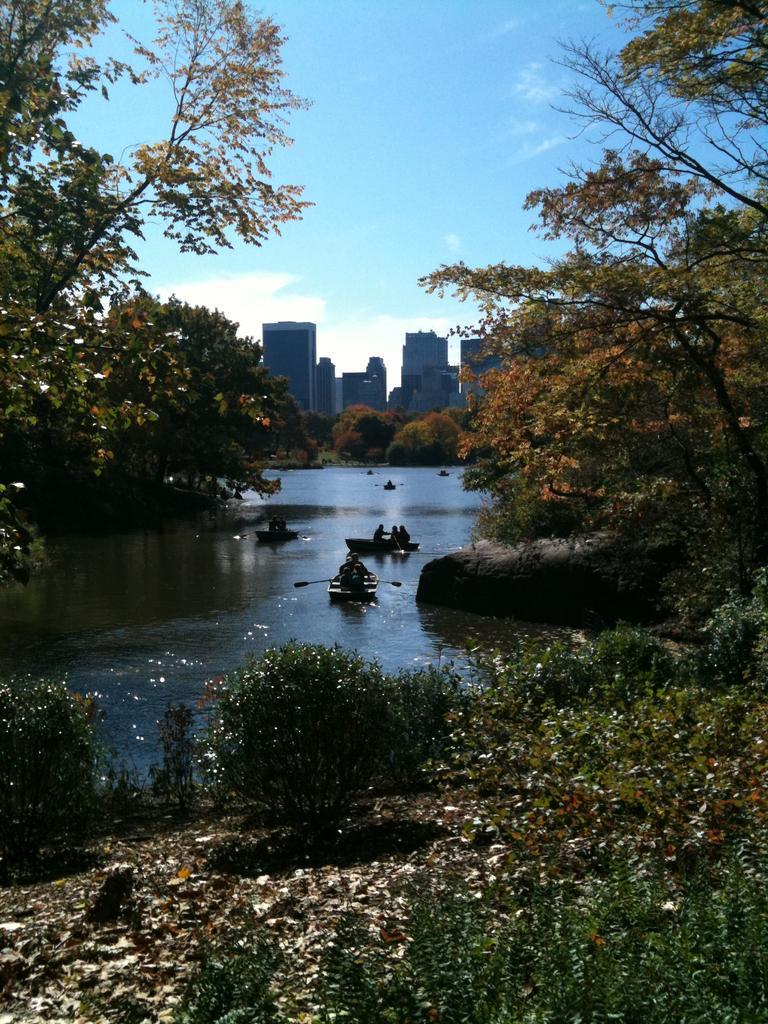Please provide a concise description of this image. In this image there are people on two boats rafting on the water, around the water there are trees, in the background of the image there are buildings. 